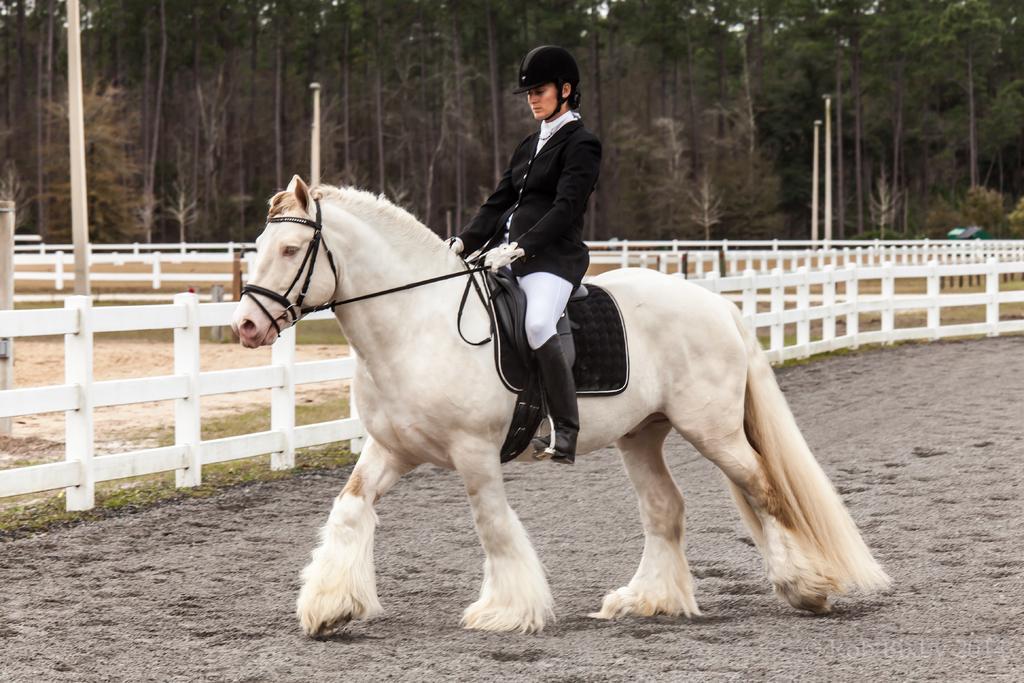Please provide a concise description of this image. In this picture there is a person siting on a horse. There are many trees at the background. 